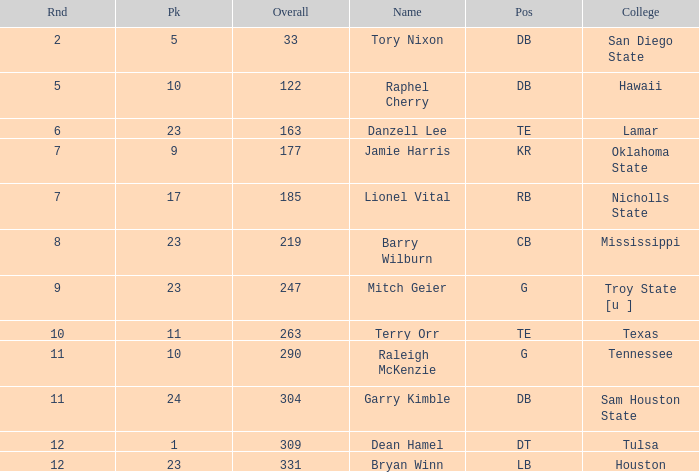How many Picks have an Overall smaller than 304, and a Position of g, and a Round smaller than 11? 1.0. 